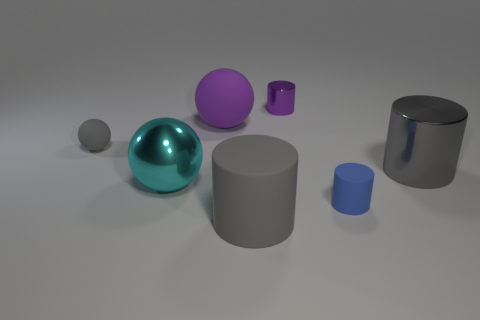Add 2 big metal things. How many objects exist? 9 Subtract all balls. How many objects are left? 4 Add 6 tiny spheres. How many tiny spheres exist? 7 Subtract 1 purple balls. How many objects are left? 6 Subtract all blue rubber cylinders. Subtract all rubber balls. How many objects are left? 4 Add 5 big matte things. How many big matte things are left? 7 